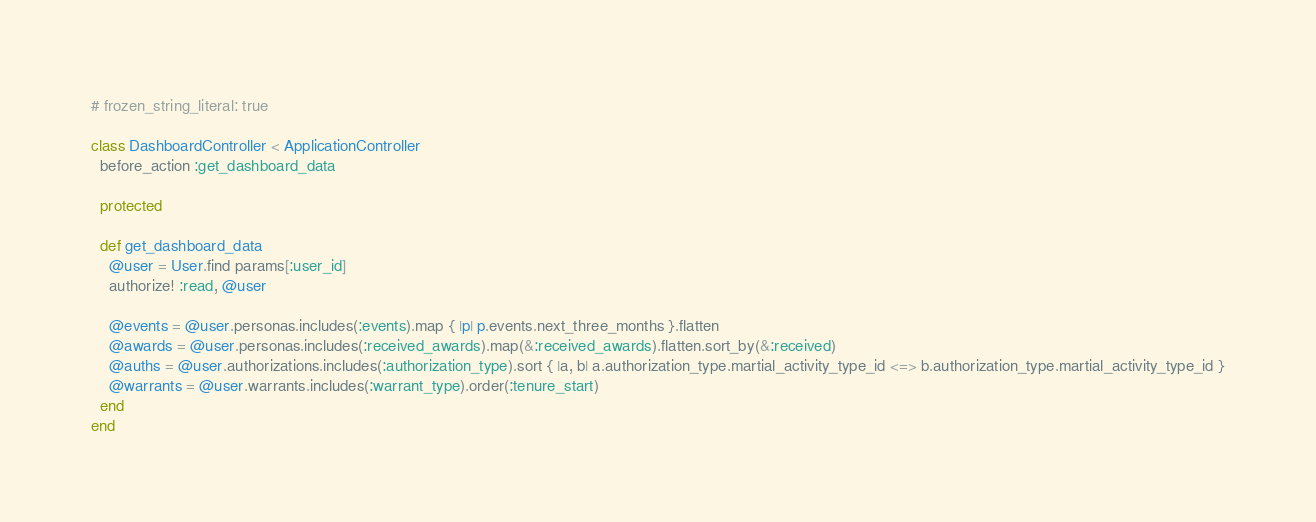<code> <loc_0><loc_0><loc_500><loc_500><_Ruby_># frozen_string_literal: true

class DashboardController < ApplicationController
  before_action :get_dashboard_data

  protected

  def get_dashboard_data
    @user = User.find params[:user_id]
    authorize! :read, @user

    @events = @user.personas.includes(:events).map { |p| p.events.next_three_months }.flatten
    @awards = @user.personas.includes(:received_awards).map(&:received_awards).flatten.sort_by(&:received)
    @auths = @user.authorizations.includes(:authorization_type).sort { |a, b| a.authorization_type.martial_activity_type_id <=> b.authorization_type.martial_activity_type_id }
    @warrants = @user.warrants.includes(:warrant_type).order(:tenure_start)
  end
end
</code> 